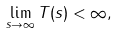Convert formula to latex. <formula><loc_0><loc_0><loc_500><loc_500>\lim _ { s \rightarrow \infty } T ( s ) < \infty ,</formula> 